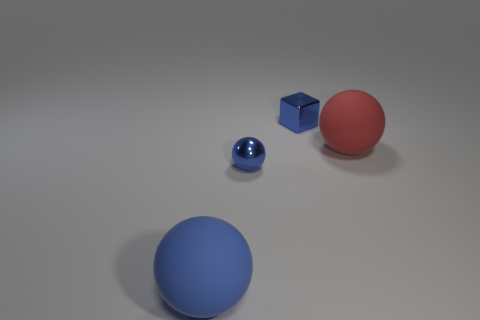Are there an equal number of big blue things to the right of the metal cube and large red matte objects that are in front of the large blue sphere?
Make the answer very short. Yes. What color is the shiny object that is the same size as the block?
Make the answer very short. Blue. Is there a thing of the same color as the tiny metallic ball?
Ensure brevity in your answer.  Yes. What number of objects are big balls that are to the left of the small blue metallic cube or big blue matte things?
Keep it short and to the point. 1. What number of other objects are the same size as the cube?
Offer a very short reply. 1. The big object on the left side of the blue shiny object that is behind the large matte ball that is right of the large blue rubber ball is made of what material?
Your answer should be compact. Rubber. What number of balls are red objects or rubber things?
Give a very brief answer. 2. Is the number of large spheres right of the blue rubber sphere greater than the number of small metallic balls that are on the right side of the small blue shiny cube?
Provide a succinct answer. Yes. There is a big thing left of the tiny ball; what number of large blue spheres are behind it?
Your answer should be very brief. 0. What number of objects are either blocks or purple shiny blocks?
Ensure brevity in your answer.  1. 